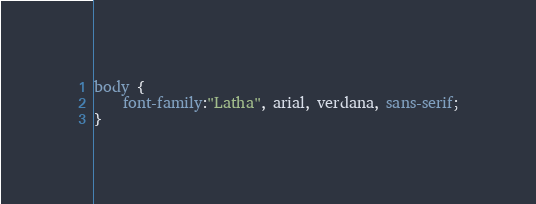<code> <loc_0><loc_0><loc_500><loc_500><_CSS_>body {
	font-family:"Latha", arial, verdana, sans-serif;
}</code> 